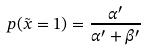<formula> <loc_0><loc_0><loc_500><loc_500>p ( \tilde { x } = 1 ) = \frac { \alpha ^ { \prime } } { \alpha ^ { \prime } + \beta ^ { \prime } }</formula> 